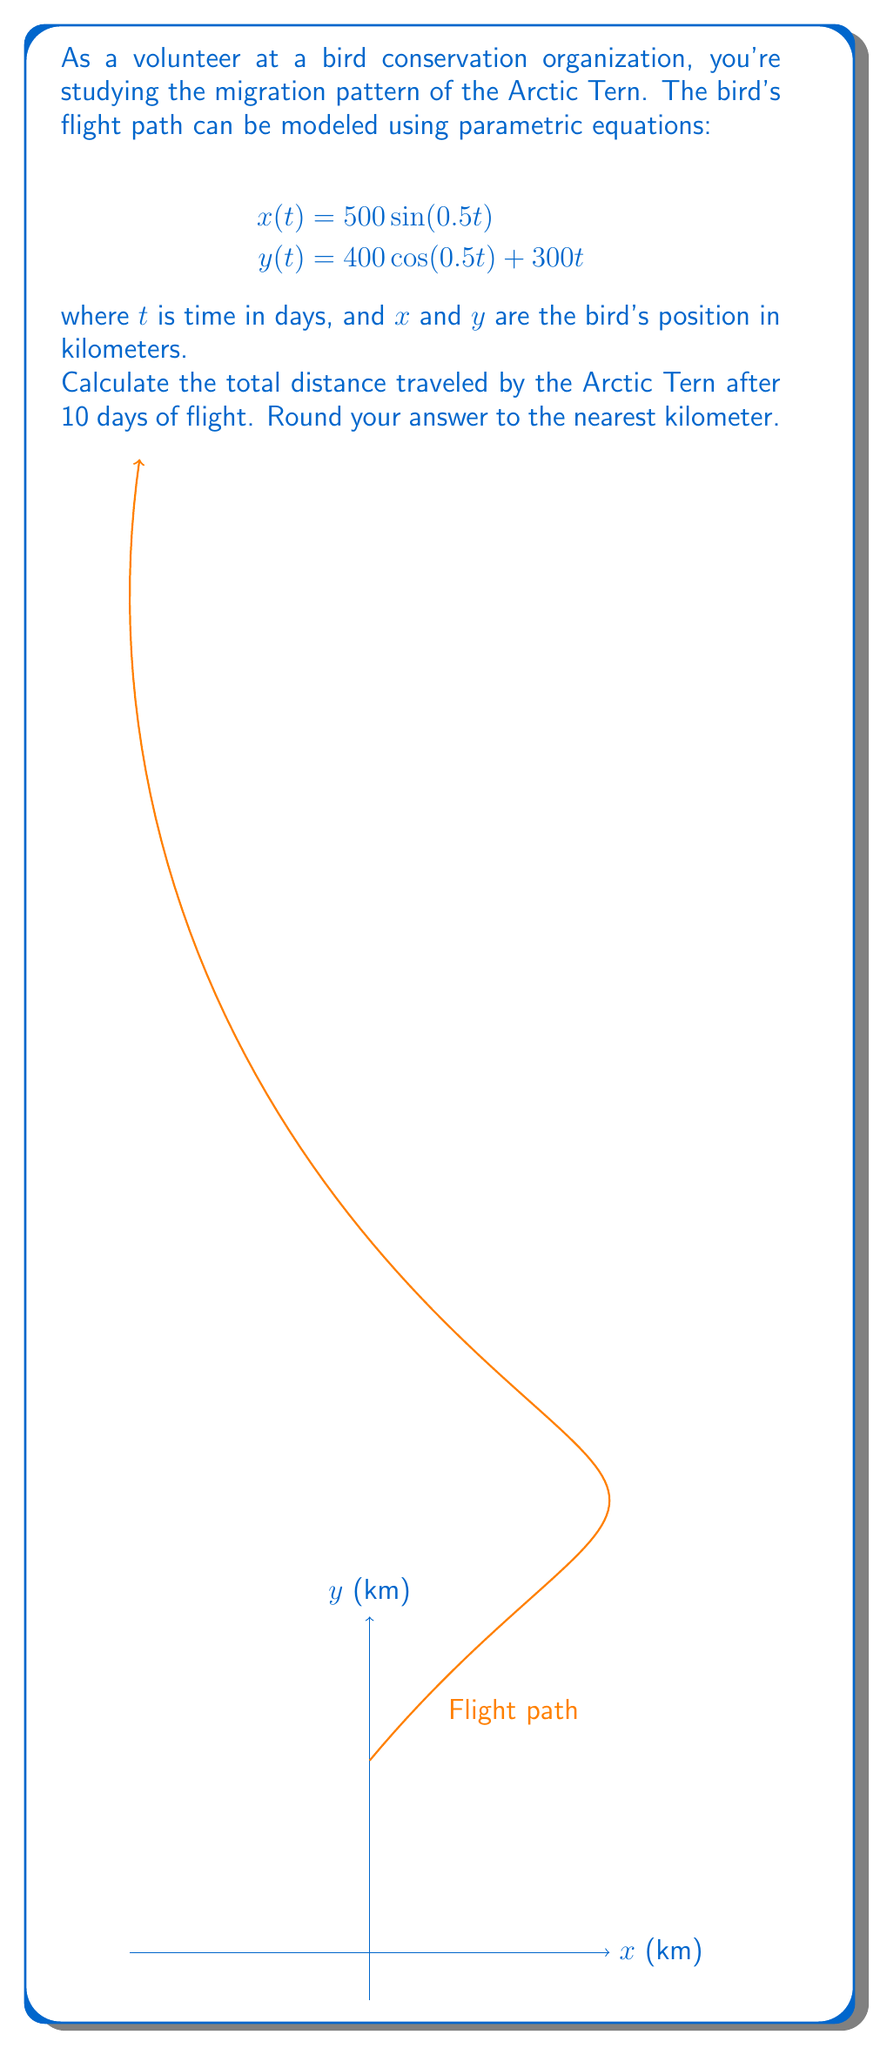What is the answer to this math problem? To solve this problem, we'll follow these steps:

1) The distance traveled is the length of the curve defined by the parametric equations. We can calculate this using the arc length formula:

   $$L = \int_0^{10} \sqrt{\left(\frac{dx}{dt}\right)^2 + \left(\frac{dy}{dt}\right)^2} dt$$

2) First, let's find $\frac{dx}{dt}$ and $\frac{dy}{dt}$:

   $$\frac{dx}{dt} = 250\cos(0.5t)$$
   $$\frac{dy}{dt} = -200\sin(0.5t) + 300$$

3) Now, let's substitute these into the arc length formula:

   $$L = \int_0^{10} \sqrt{(250\cos(0.5t))^2 + (-200\sin(0.5t) + 300)^2} dt$$

4) Simplify under the square root:

   $$L = \int_0^{10} \sqrt{62500\cos^2(0.5t) + 40000\sin^2(0.5t) - 120000\sin(0.5t) + 90000} dt$$

5) This integral is too complex to solve analytically. We need to use numerical integration. Using a computer or calculator with numerical integration capabilities, we can evaluate this integral:

   $$L \approx 3052.76 \text{ km}$$

6) Rounding to the nearest kilometer:

   $$L \approx 3053 \text{ km}$$
Answer: 3053 km 